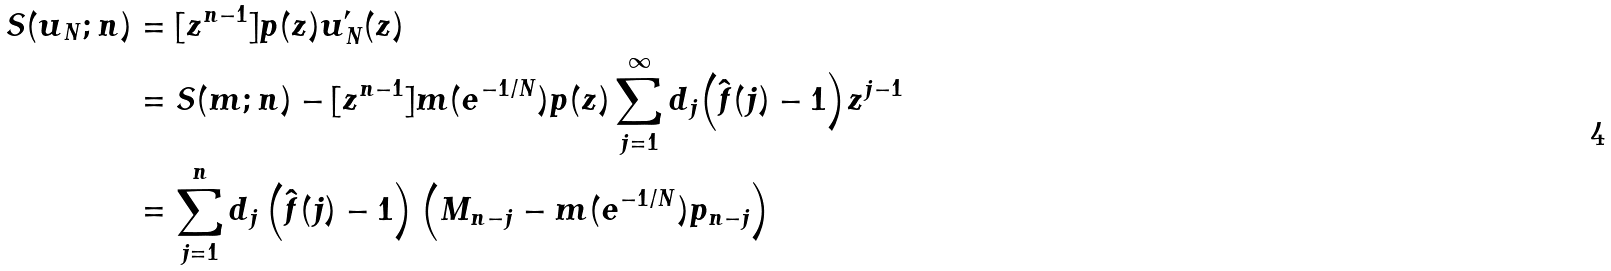<formula> <loc_0><loc_0><loc_500><loc_500>S ( u _ { N } ; n ) & = [ z ^ { n - 1 } ] p ( z ) u _ { N } ^ { \prime } ( z ) \\ & = S ( m ; n ) - [ z ^ { n - 1 } ] m ( e ^ { - 1 / N } ) p ( z ) \sum _ { j = 1 } ^ { \infty } d _ { j } { \left ( \hat { f } ( j ) - 1 \right ) } z ^ { j - 1 } \\ & = \sum _ { j = 1 } ^ { n } d _ { j } \left ( \hat { f } ( j ) - 1 \right ) \left ( M _ { n - j } - m ( e ^ { - 1 / N } ) p _ { n - j } \right )</formula> 